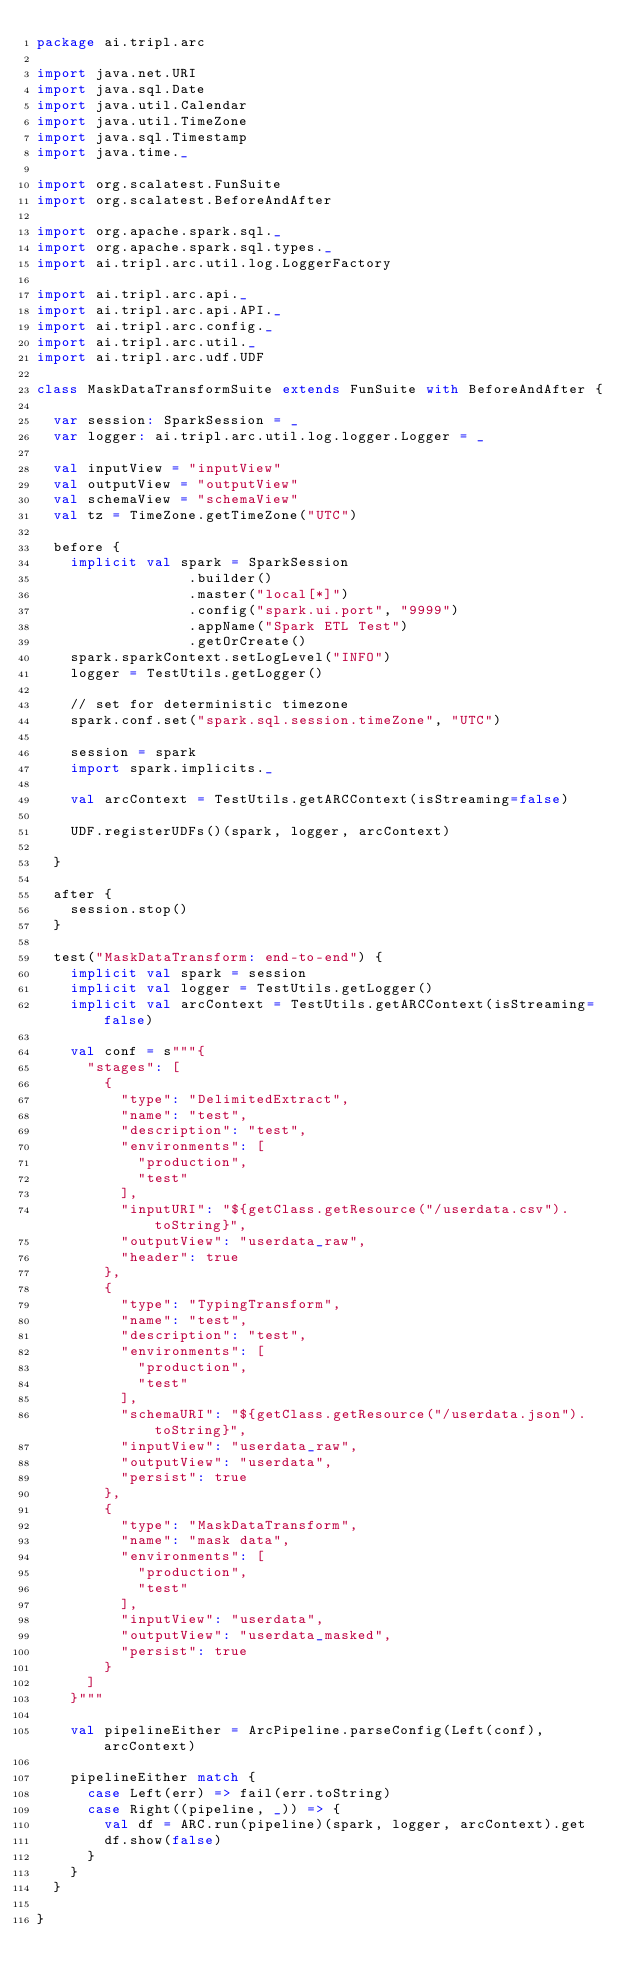Convert code to text. <code><loc_0><loc_0><loc_500><loc_500><_Scala_>package ai.tripl.arc

import java.net.URI
import java.sql.Date
import java.util.Calendar
import java.util.TimeZone
import java.sql.Timestamp
import java.time._

import org.scalatest.FunSuite
import org.scalatest.BeforeAndAfter

import org.apache.spark.sql._
import org.apache.spark.sql.types._
import ai.tripl.arc.util.log.LoggerFactory

import ai.tripl.arc.api._
import ai.tripl.arc.api.API._
import ai.tripl.arc.config._
import ai.tripl.arc.util._
import ai.tripl.arc.udf.UDF

class MaskDataTransformSuite extends FunSuite with BeforeAndAfter {

  var session: SparkSession = _
  var logger: ai.tripl.arc.util.log.logger.Logger = _

  val inputView = "inputView"
  val outputView = "outputView"
  val schemaView = "schemaView"
  val tz = TimeZone.getTimeZone("UTC")

  before {
    implicit val spark = SparkSession
                  .builder()
                  .master("local[*]")
                  .config("spark.ui.port", "9999")
                  .appName("Spark ETL Test")
                  .getOrCreate()
    spark.sparkContext.setLogLevel("INFO")
    logger = TestUtils.getLogger()

    // set for deterministic timezone
    spark.conf.set("spark.sql.session.timeZone", "UTC")

    session = spark
    import spark.implicits._

    val arcContext = TestUtils.getARCContext(isStreaming=false)

    UDF.registerUDFs()(spark, logger, arcContext)

  }

  after {
    session.stop()
  }

  test("MaskDataTransform: end-to-end") {
    implicit val spark = session
    implicit val logger = TestUtils.getLogger()
    implicit val arcContext = TestUtils.getARCContext(isStreaming=false)

    val conf = s"""{
      "stages": [
        {
          "type": "DelimitedExtract",
          "name": "test",
          "description": "test",
          "environments": [
            "production",
            "test"
          ],
          "inputURI": "${getClass.getResource("/userdata.csv").toString}",
          "outputView": "userdata_raw",
          "header": true
        },
        {
          "type": "TypingTransform",
          "name": "test",
          "description": "test",
          "environments": [
            "production",
            "test"
          ],
          "schemaURI": "${getClass.getResource("/userdata.json").toString}",
          "inputView": "userdata_raw",
          "outputView": "userdata",
          "persist": true
        },
        {
          "type": "MaskDataTransform",
          "name": "mask data",
          "environments": [
            "production",
            "test"
          ],
          "inputView": "userdata",
          "outputView": "userdata_masked",
          "persist": true
        }          
      ]
    }"""

    val pipelineEither = ArcPipeline.parseConfig(Left(conf), arcContext)

    pipelineEither match {
      case Left(err) => fail(err.toString)
      case Right((pipeline, _)) => {
        val df = ARC.run(pipeline)(spark, logger, arcContext).get
        df.show(false)
      }
    }
  }      

}
</code> 